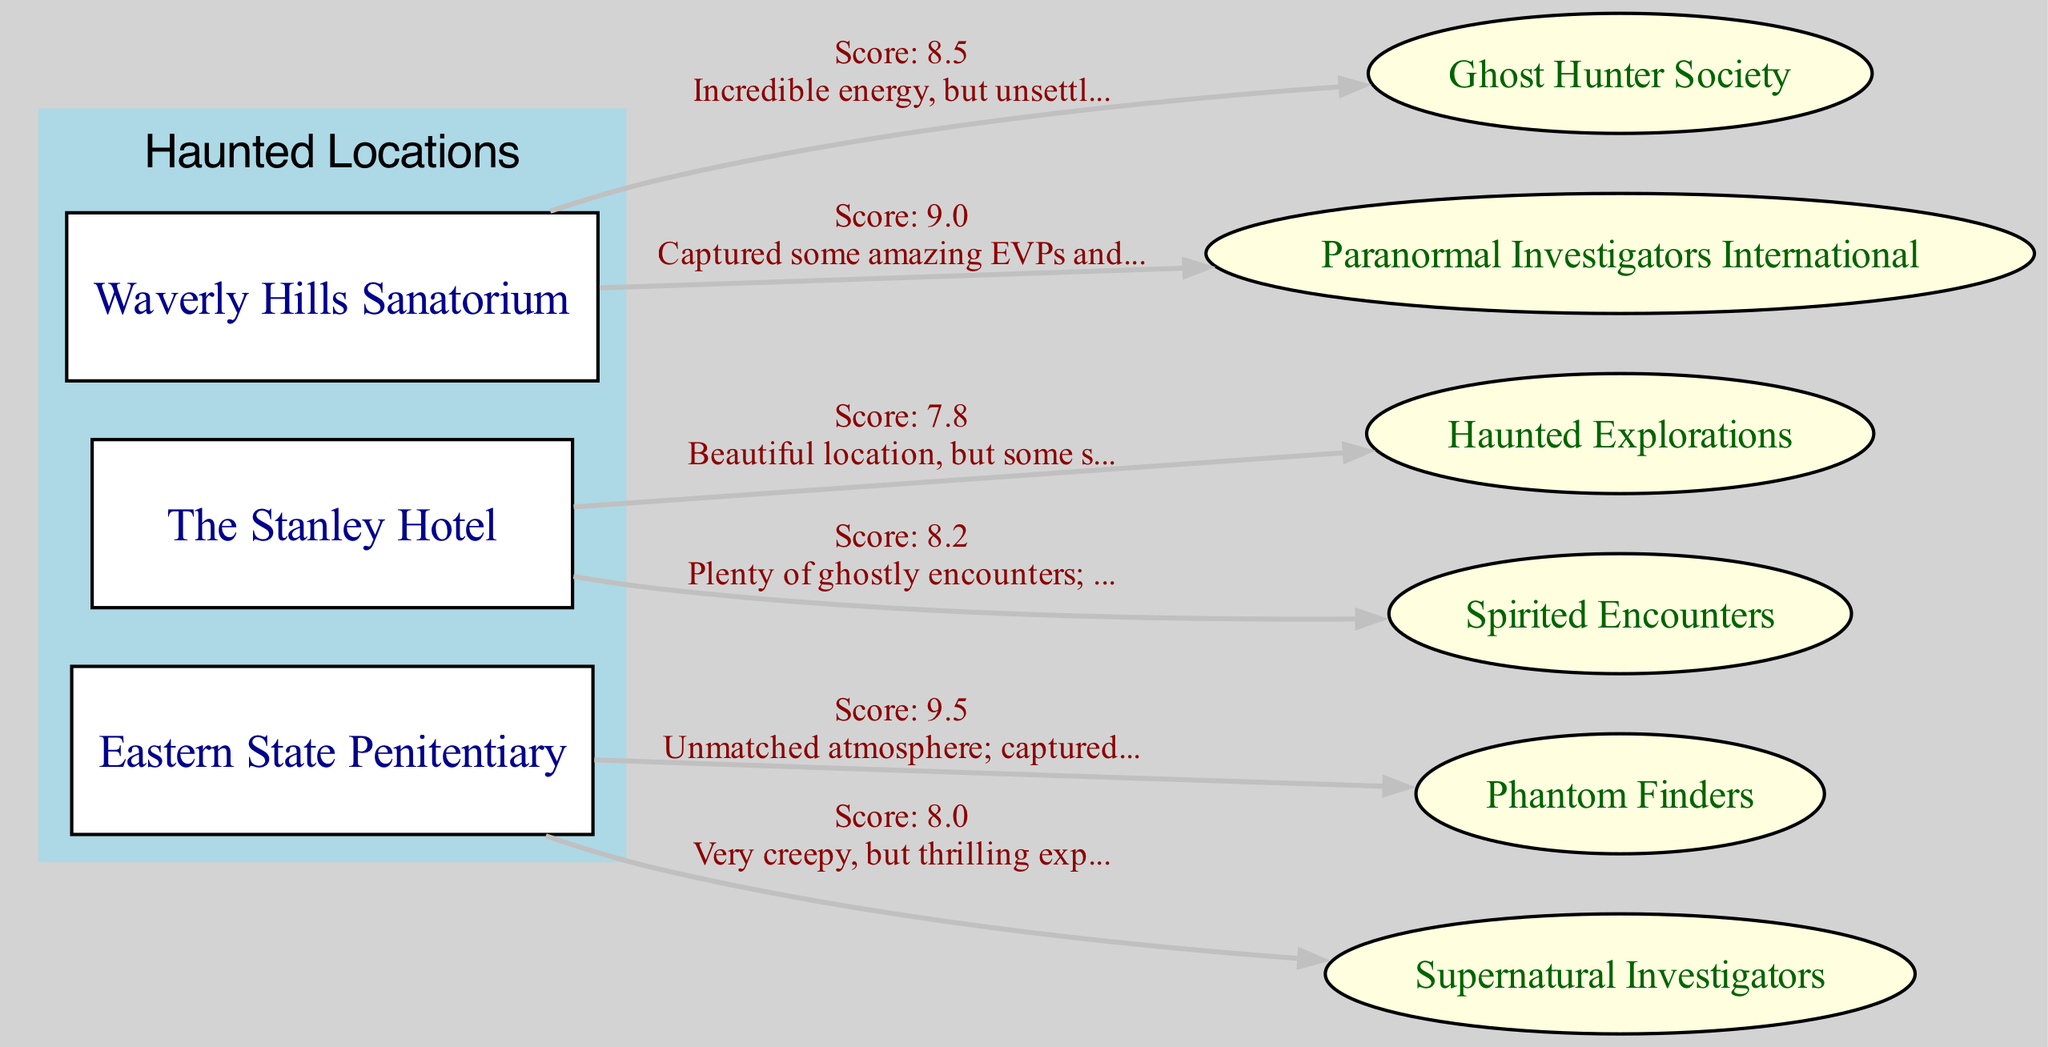What is the review score given by the Paranormal Investigators International? The review score given by the Paranormal Investigators International is listed next to the edge connecting to the Waverly Hills Sanatorium. It states "Score: 9.0" as part of the information from that edge.
Answer: 9.0 Which haunted location has tenants with the highest average review score? To find the highest average review score, we need to calculate the average scores for each location: Waverly Hills Sanatorium (8.5 + 9.0) / 2 = 8.75, The Stanley Hotel (7.8 + 8.2) / 2 = 8.0, Eastern State Penitentiary (9.5 + 8.0) / 2 = 8.75. Waverly Hills and Eastern State both have the highest average of 8.75.
Answer: Waverly Hills Sanatorium and Eastern State Penitentiary What feedback did the tenant of The Stanley Hotel provide? The feedback from the tenant "Haunted Explorations" regarding The Stanley Hotel is shown on the edge labeled with its review score. It says "Beautiful location, but some staff seemed uneasy." We look at the edge connecting the tenant to the location for this information.
Answer: Beautiful location, but some staff seemed uneasy How many tenants rented the Waverly Hills Sanatorium? By counting the edges connected to the Waverly Hills Sanatorium node, we can see there are two tenants, (Ghost Hunter Society and Paranormal Investigators International) that rented it.
Answer: 2 Which tenant recorded the lowest review score at Eastern State Penitentiary? The review scores of the tenants for Eastern State Penitentiary are 9.5 and 8.0. The tenant with the lowest score is "Supernatural Investigators" with a review score of 8.0, indicated next to its edge to the location.
Answer: Supernatural Investigators 